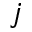Convert formula to latex. <formula><loc_0><loc_0><loc_500><loc_500>j</formula> 